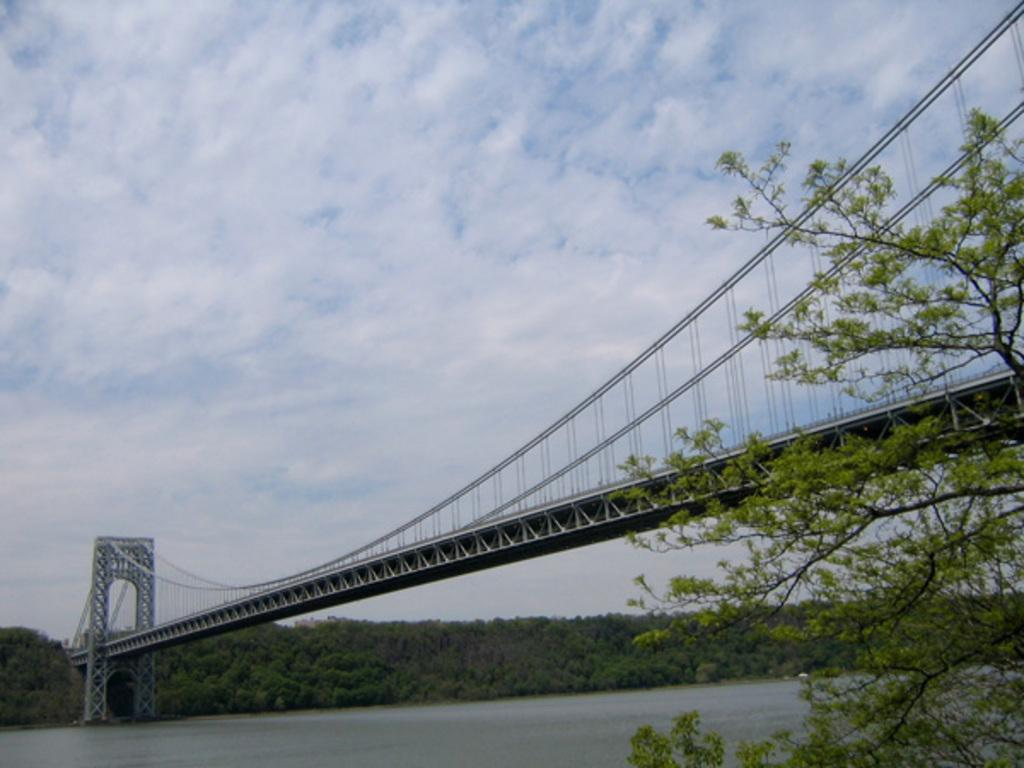What is present in the picture that represents a body of water? There is water in the picture. What structure can be seen crossing over the water in the picture? There is a bridge in the picture. What type of vegetation is visible in the picture? There are trees in the picture. What can be seen in the distance behind the water and bridge in the picture? The sky is visible in the background of the picture. What type of grass is the achiever walking on in the picture? There is no achiever or grass present in the picture; it features water, a bridge, trees, and the sky. What medical advice can be obtained from the doctor in the picture? There is no doctor present in the picture. 